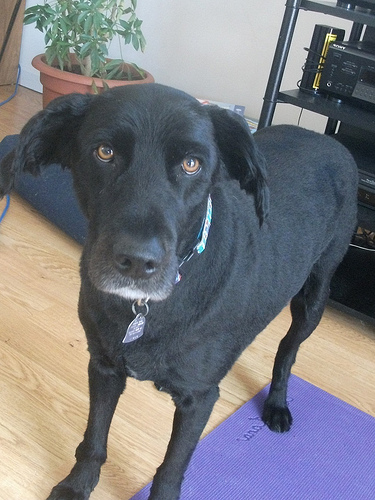<image>
Is the dog on the mate? Yes. Looking at the image, I can see the dog is positioned on top of the mate, with the mate providing support. Where is the dog in relation to the blanket? Is it on the blanket? No. The dog is not positioned on the blanket. They may be near each other, but the dog is not supported by or resting on top of the blanket. 